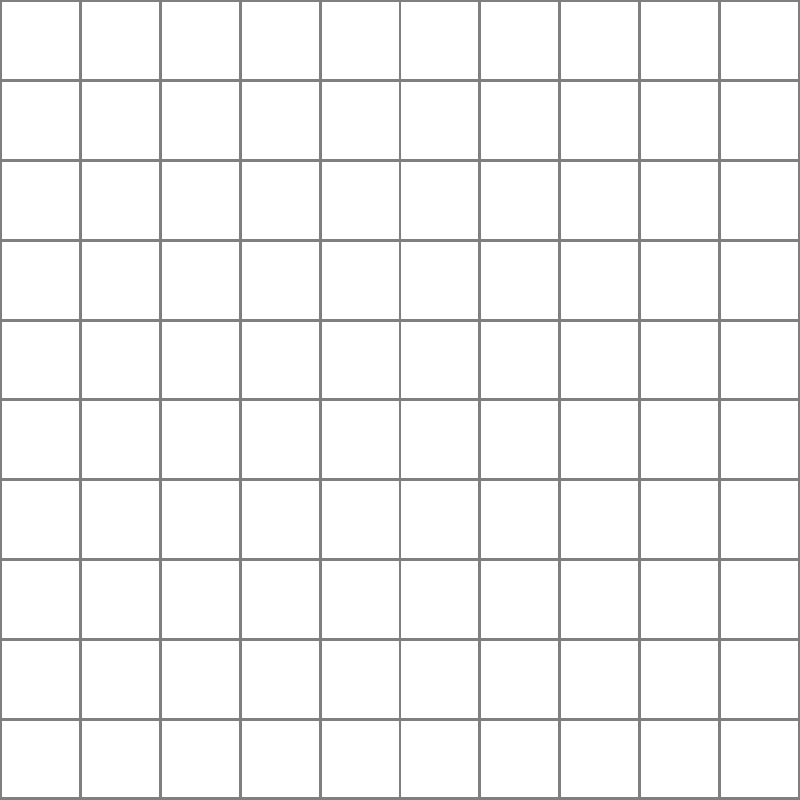As a seamstress with experience in various fabric types, identify the weave pattern shown in the image above. How does this weave structure contribute to the fabric's properties, and how might it influence your choice for a particular garment design? To identify the weave pattern and understand its properties, let's follow these steps:

1. Observe the pattern: The image shows a regular, alternating pattern of threads going over and under each other.

2. Identify the weave: This is a plain weave, also known as a tabby weave. It's the simplest and most common weave pattern.

3. Analyze the structure:
   - Each weft thread (horizontal) passes alternately over and under each warp thread (vertical).
   - The pattern repeats every two threads in both directions.

4. Consider the properties of plain weave fabrics:
   - Durability: The frequent interlacing makes the fabric strong and resistant to tearing.
   - Stability: The tight weave reduces shifting and fraying of threads.
   - Less drape: Plain weaves tend to be less fluid and have more body than other weaves.
   - Good breathability: The simple structure allows for air circulation.

5. Garment design considerations:
   - Suitable for structured garments that need to hold their shape.
   - Ideal for items that require durability, such as work uniforms or children's clothing.
   - May not be the best choice for designs requiring a lot of drape or fluidity.
   - Good for warm-weather clothing due to breathability.

6. Union perspective:
   - Plain weave fabrics are often more economical to produce, which could be a consideration in labor negotiations regarding production quotas or wages.
   - The durability of plain weave fabrics might be emphasized in discussions about the quality and longevity of union-made garments.
Answer: Plain weave; durable and stable but less drapey, suitable for structured or breathable garments. 